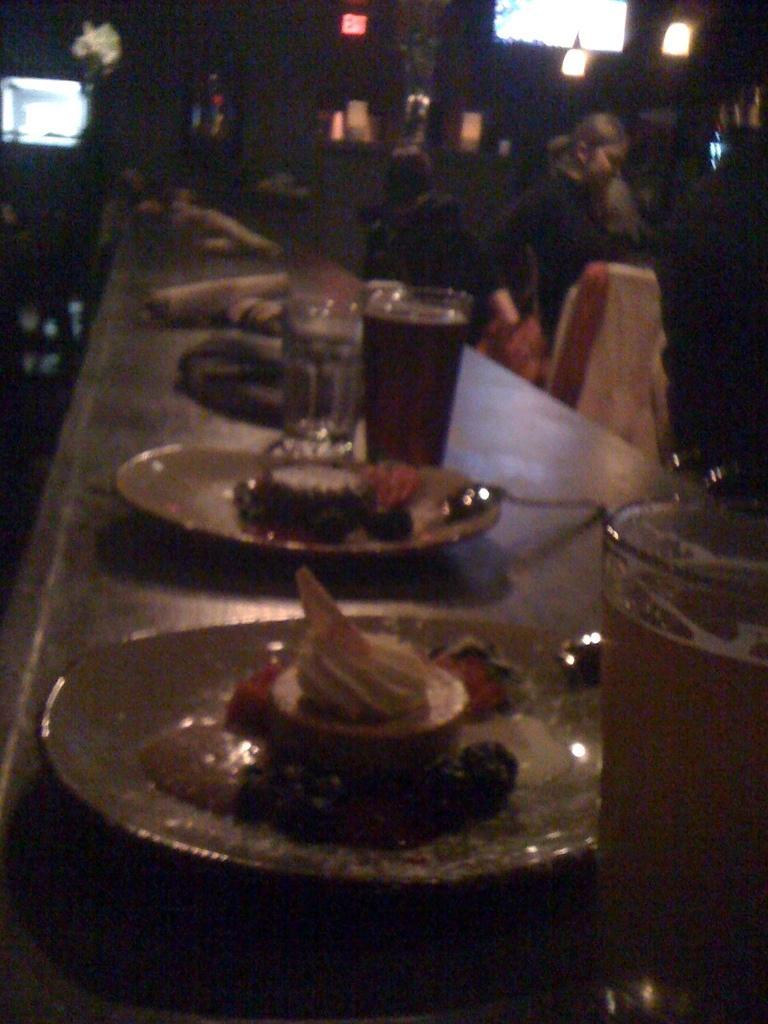Could you give a brief overview of what you see in this image? This image is taken dark where we can see food items and spoons are kept on the plate, glasses with drinks and a few more things are kept on the surface. The background of the image is blurred, where we can see a few more people, we can see ceiling lights, monitor, exit board and few more things. 